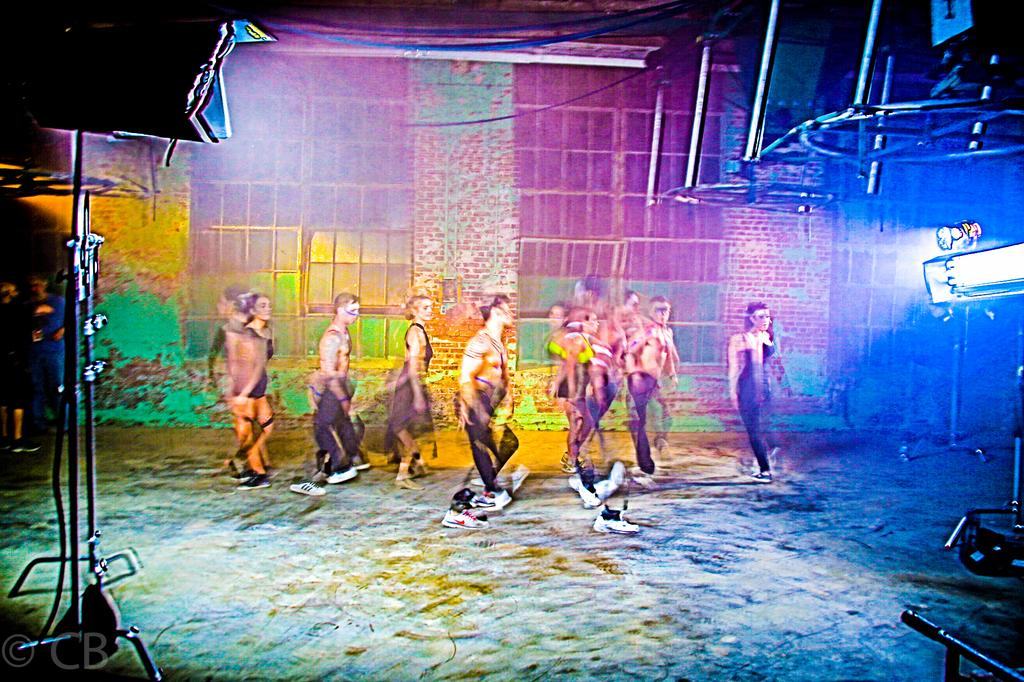Who or what is present in the image? There are people in the image. What can be seen in the background of the image? There is a wall in the background of the image. How does the zephyr affect the people in the image? There is no mention of a zephyr in the image, so it cannot be determined how it would affect the people. 